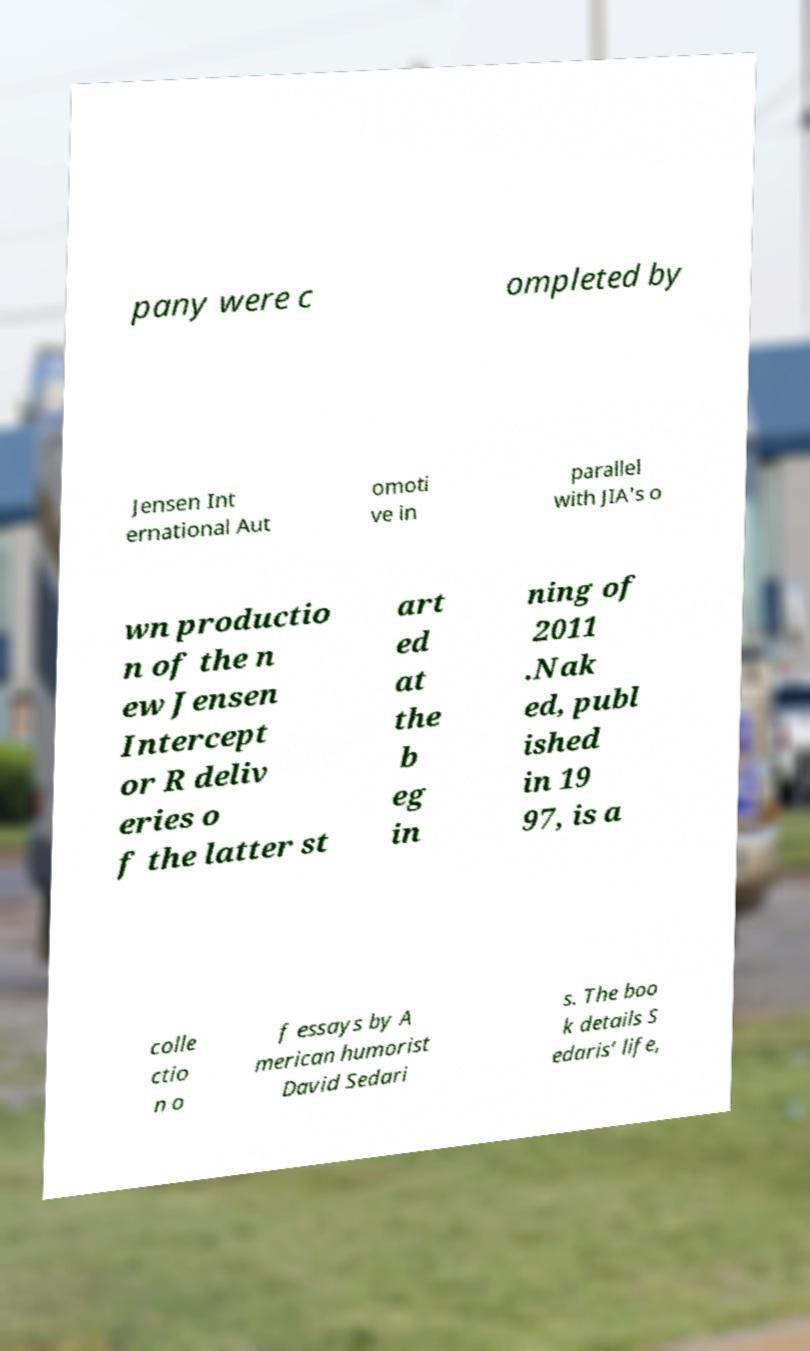For documentation purposes, I need the text within this image transcribed. Could you provide that? pany were c ompleted by Jensen Int ernational Aut omoti ve in parallel with JIA's o wn productio n of the n ew Jensen Intercept or R deliv eries o f the latter st art ed at the b eg in ning of 2011 .Nak ed, publ ished in 19 97, is a colle ctio n o f essays by A merican humorist David Sedari s. The boo k details S edaris’ life, 